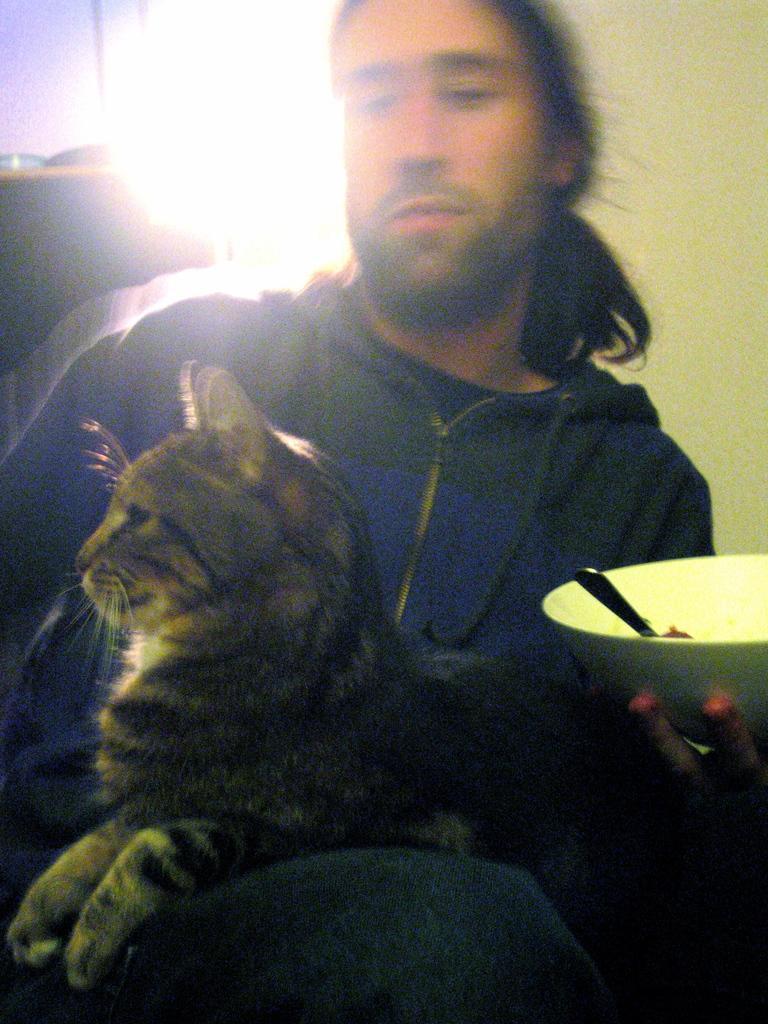Describe this image in one or two sentences. A man is sitting with a bowl in his hand. A cat is sitting on him. 